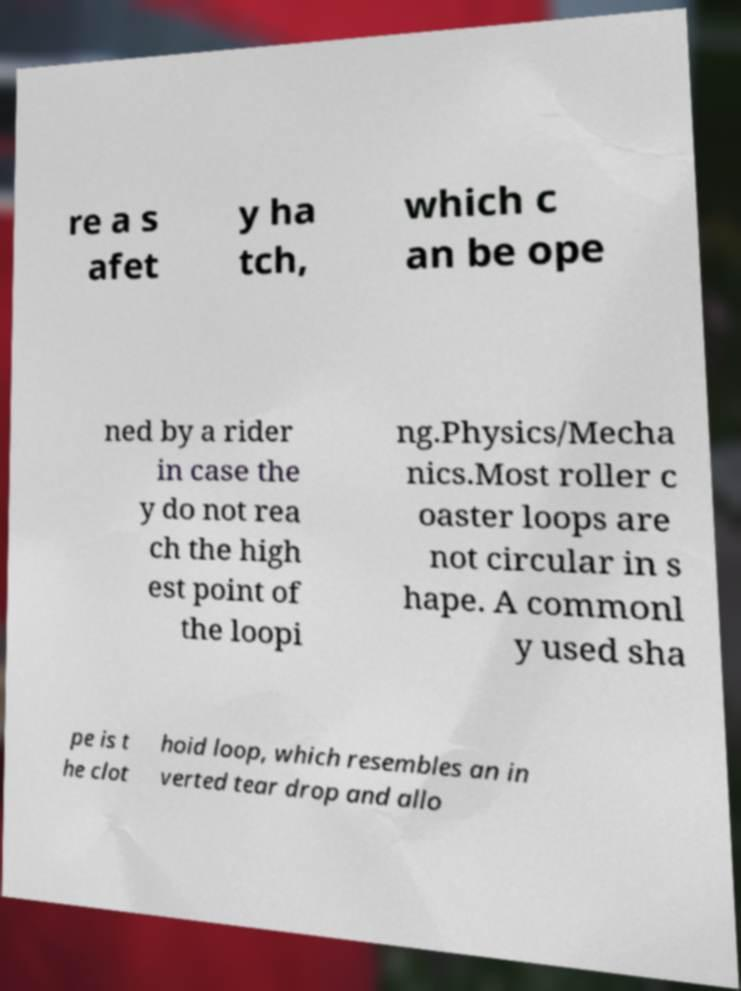There's text embedded in this image that I need extracted. Can you transcribe it verbatim? re a s afet y ha tch, which c an be ope ned by a rider in case the y do not rea ch the high est point of the loopi ng.Physics/Mecha nics.Most roller c oaster loops are not circular in s hape. A commonl y used sha pe is t he clot hoid loop, which resembles an in verted tear drop and allo 